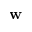Convert formula to latex. <formula><loc_0><loc_0><loc_500><loc_500>w</formula> 